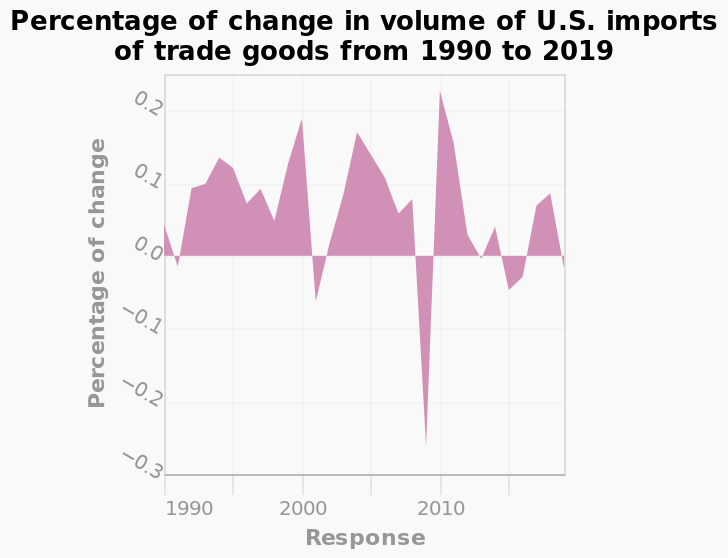<image>
What is the minimum value on the x-axis? The minimum value on the x-axis is 1990. What is the name given to the area graph? The area graph is named "Percentage of change in volume of U.S. imports of trade goods from 1990 to 2019." 